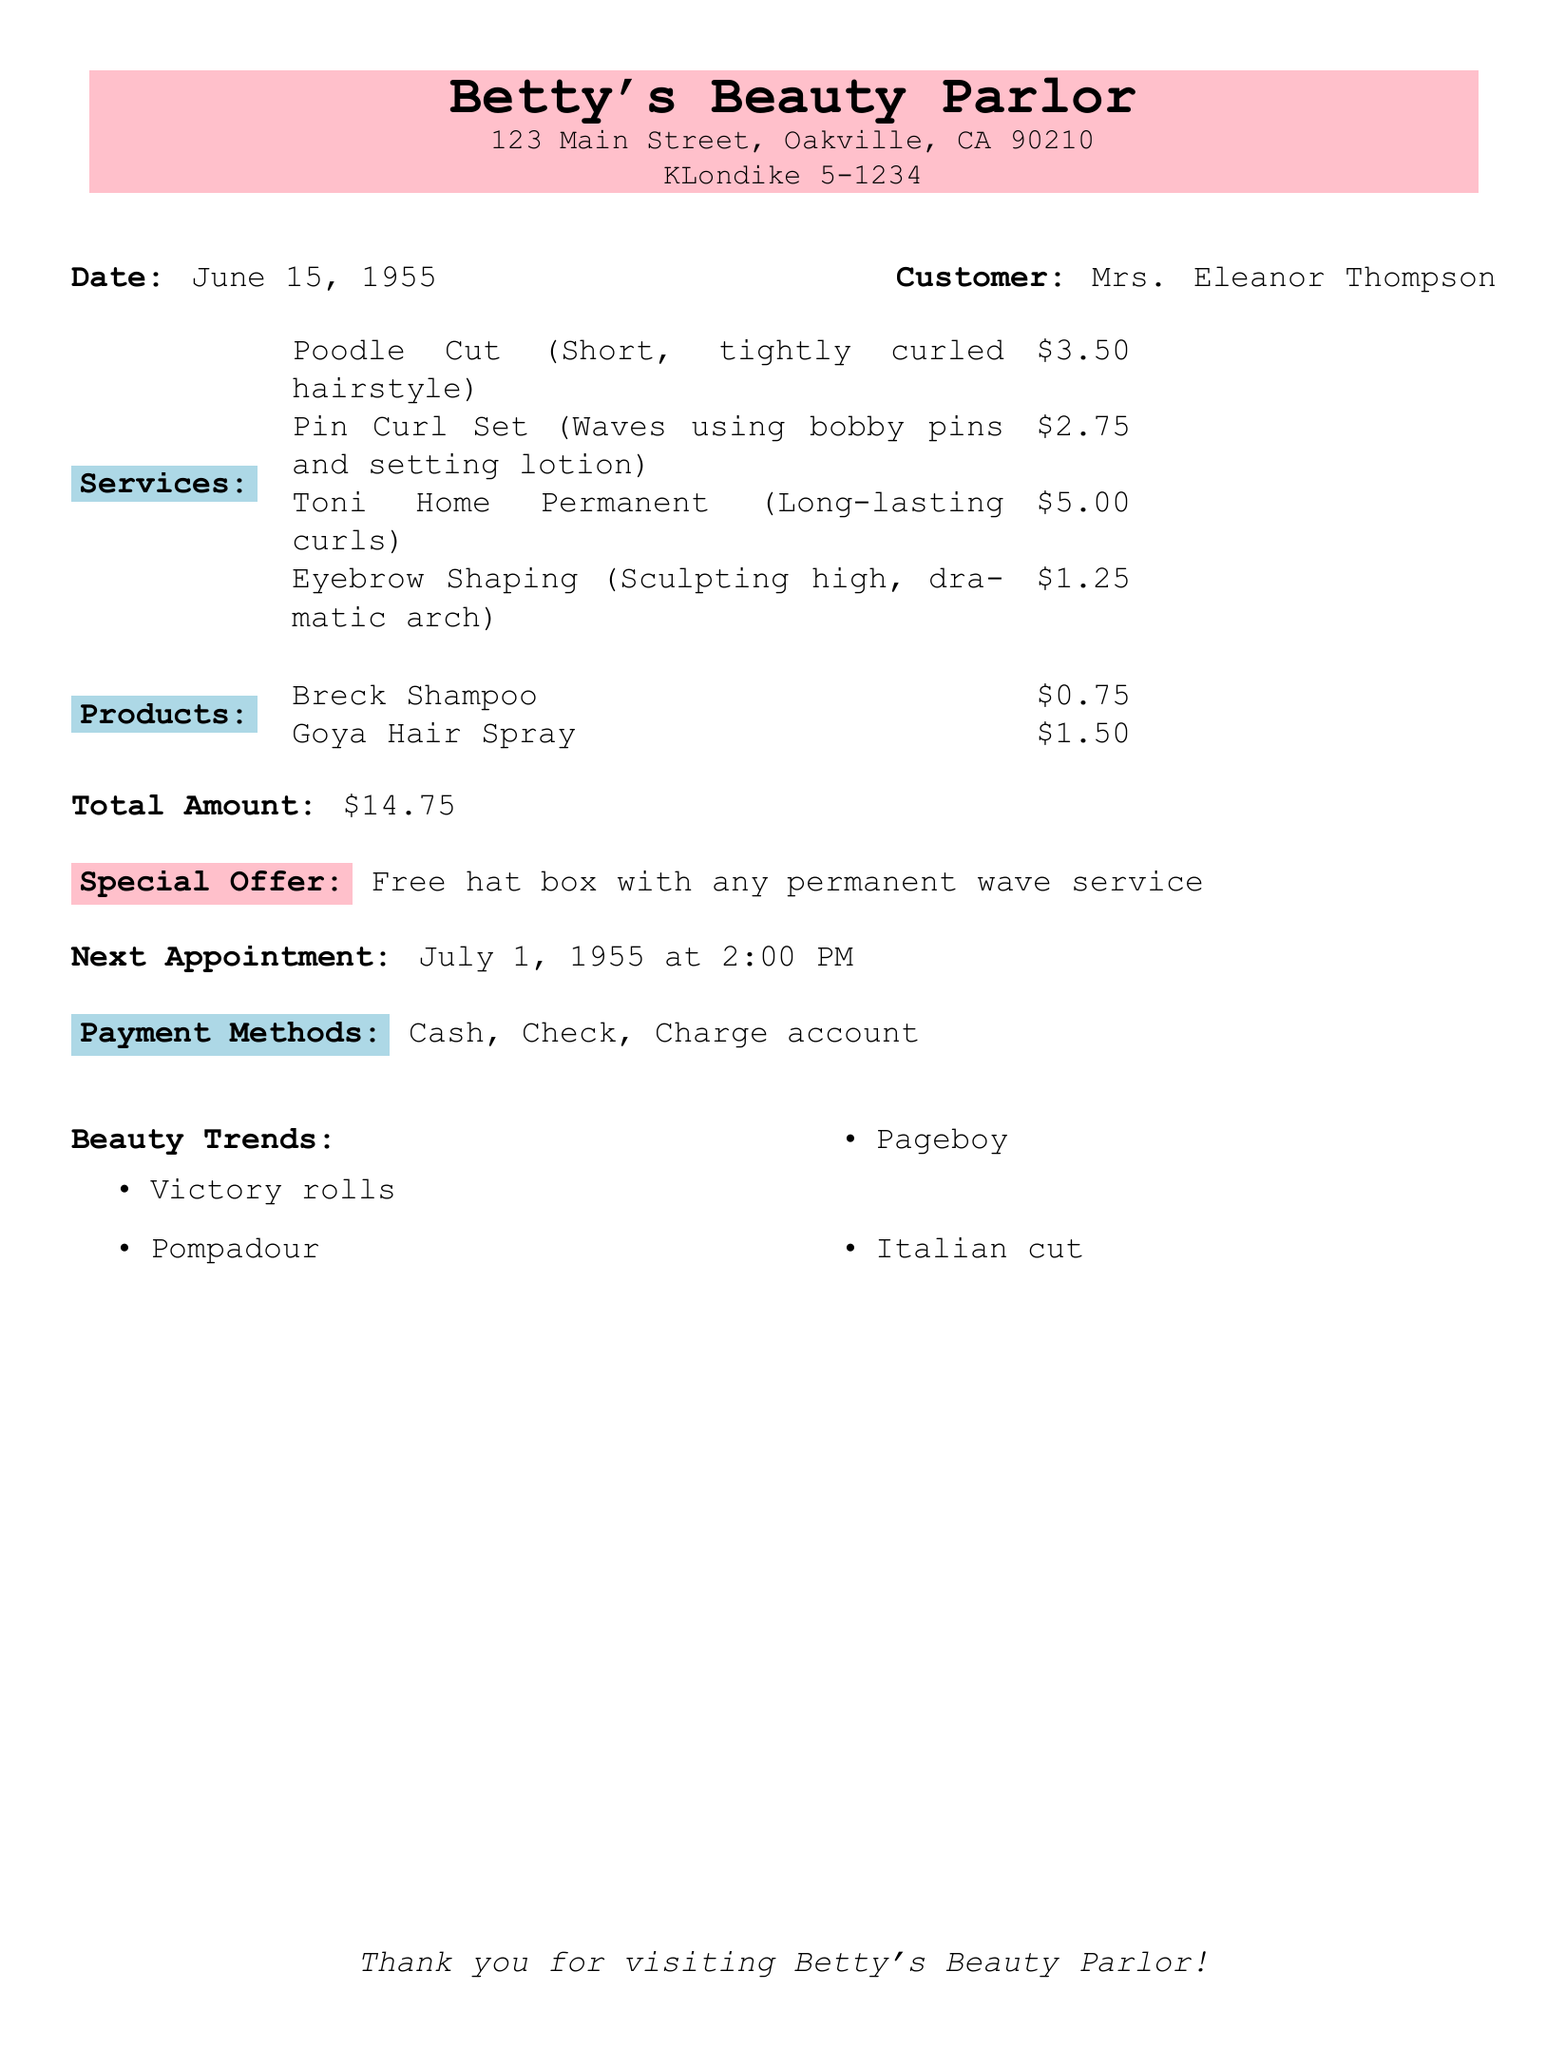what is the name of the salon? The name of the salon is prominently displayed at the top of the document.
Answer: Betty's Beauty Parlor who is the customer? The customer's name is provided in the document.
Answer: Mrs. Eleanor Thompson what hairstyle was popularized by Lucille Ball? This hairstyle is mentioned in the description of one of the services.
Answer: Poodle Cut what is the price of a Toni Home Permanent? The price is listed next to the service provided in the document.
Answer: $5.00 how much does eyebrow shaping cost? The cost for the eyebrow shaping service is provided in the services section.
Answer: $1.25 what is the total amount due for the services rendered? The total amount is clearly stated at the end of the receipt.
Answer: $14.75 what is the special offer available? The special offer is mentioned in the document, providing more information about a promotion.
Answer: Free hat box with any permanent wave service when is the next appointment scheduled? The date and time for the next appointment are specified in the document.
Answer: July 1, 1955 at 2:00 PM which payments methods are accepted? The accepted payment methods are listed toward the end of the document.
Answer: Cash, Check, Charge account 